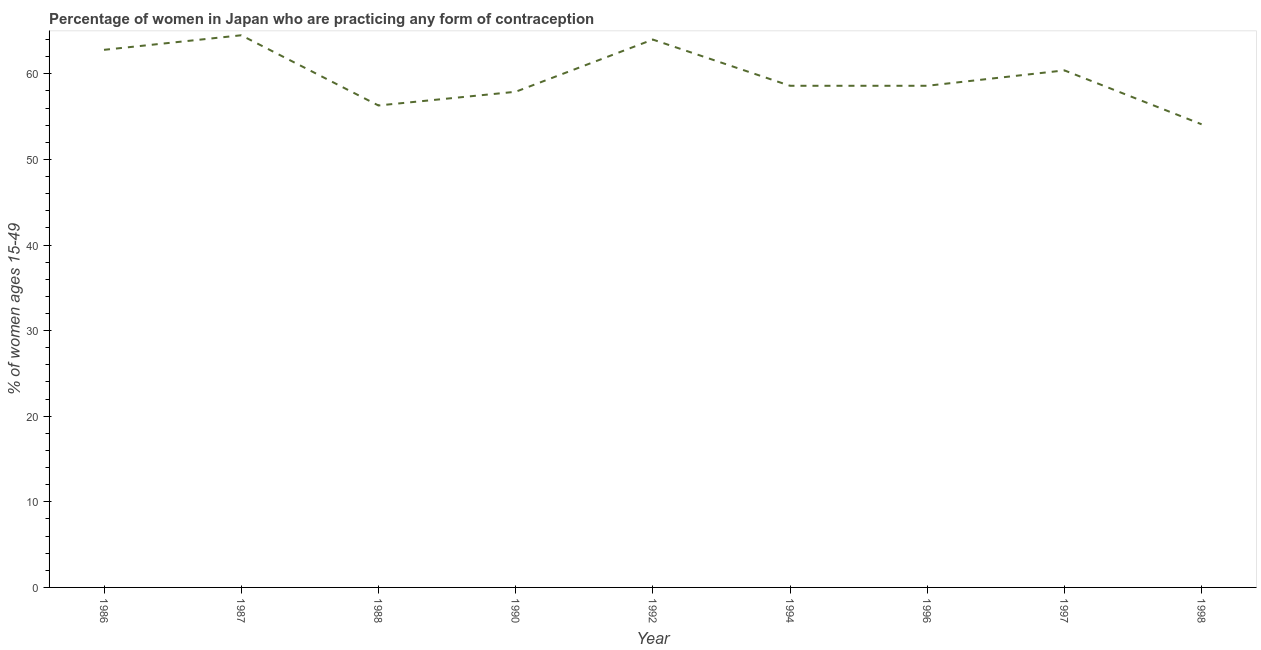What is the contraceptive prevalence in 1992?
Your answer should be compact. 64. Across all years, what is the maximum contraceptive prevalence?
Offer a terse response. 64.5. Across all years, what is the minimum contraceptive prevalence?
Provide a succinct answer. 54.1. In which year was the contraceptive prevalence minimum?
Keep it short and to the point. 1998. What is the sum of the contraceptive prevalence?
Offer a very short reply. 537.2. What is the difference between the contraceptive prevalence in 1988 and 1997?
Offer a terse response. -4.1. What is the average contraceptive prevalence per year?
Provide a succinct answer. 59.69. What is the median contraceptive prevalence?
Keep it short and to the point. 58.6. In how many years, is the contraceptive prevalence greater than 62 %?
Make the answer very short. 3. What is the ratio of the contraceptive prevalence in 1987 to that in 1990?
Give a very brief answer. 1.11. Is the difference between the contraceptive prevalence in 1992 and 1994 greater than the difference between any two years?
Your response must be concise. No. What is the difference between the highest and the second highest contraceptive prevalence?
Your answer should be compact. 0.5. What is the difference between the highest and the lowest contraceptive prevalence?
Make the answer very short. 10.4. In how many years, is the contraceptive prevalence greater than the average contraceptive prevalence taken over all years?
Provide a short and direct response. 4. Does the contraceptive prevalence monotonically increase over the years?
Your answer should be very brief. No. How many years are there in the graph?
Your response must be concise. 9. What is the difference between two consecutive major ticks on the Y-axis?
Make the answer very short. 10. Are the values on the major ticks of Y-axis written in scientific E-notation?
Provide a succinct answer. No. What is the title of the graph?
Make the answer very short. Percentage of women in Japan who are practicing any form of contraception. What is the label or title of the X-axis?
Your answer should be very brief. Year. What is the label or title of the Y-axis?
Your answer should be very brief. % of women ages 15-49. What is the % of women ages 15-49 of 1986?
Ensure brevity in your answer.  62.8. What is the % of women ages 15-49 of 1987?
Make the answer very short. 64.5. What is the % of women ages 15-49 of 1988?
Provide a succinct answer. 56.3. What is the % of women ages 15-49 of 1990?
Make the answer very short. 57.9. What is the % of women ages 15-49 in 1994?
Offer a very short reply. 58.6. What is the % of women ages 15-49 of 1996?
Your answer should be compact. 58.6. What is the % of women ages 15-49 in 1997?
Provide a short and direct response. 60.4. What is the % of women ages 15-49 in 1998?
Keep it short and to the point. 54.1. What is the difference between the % of women ages 15-49 in 1986 and 1987?
Make the answer very short. -1.7. What is the difference between the % of women ages 15-49 in 1986 and 1992?
Offer a very short reply. -1.2. What is the difference between the % of women ages 15-49 in 1986 and 1996?
Offer a terse response. 4.2. What is the difference between the % of women ages 15-49 in 1986 and 1997?
Offer a terse response. 2.4. What is the difference between the % of women ages 15-49 in 1987 and 1988?
Offer a very short reply. 8.2. What is the difference between the % of women ages 15-49 in 1987 and 1990?
Your answer should be compact. 6.6. What is the difference between the % of women ages 15-49 in 1987 and 1994?
Your answer should be very brief. 5.9. What is the difference between the % of women ages 15-49 in 1988 and 1990?
Your response must be concise. -1.6. What is the difference between the % of women ages 15-49 in 1988 and 1992?
Offer a terse response. -7.7. What is the difference between the % of women ages 15-49 in 1988 and 1996?
Your response must be concise. -2.3. What is the difference between the % of women ages 15-49 in 1988 and 1997?
Give a very brief answer. -4.1. What is the difference between the % of women ages 15-49 in 1988 and 1998?
Make the answer very short. 2.2. What is the difference between the % of women ages 15-49 in 1990 and 1998?
Your response must be concise. 3.8. What is the difference between the % of women ages 15-49 in 1992 and 1994?
Your response must be concise. 5.4. What is the difference between the % of women ages 15-49 in 1992 and 1996?
Offer a terse response. 5.4. What is the difference between the % of women ages 15-49 in 1992 and 1998?
Offer a terse response. 9.9. What is the difference between the % of women ages 15-49 in 1994 and 1996?
Offer a very short reply. 0. What is the difference between the % of women ages 15-49 in 1994 and 1998?
Ensure brevity in your answer.  4.5. What is the difference between the % of women ages 15-49 in 1996 and 1997?
Make the answer very short. -1.8. What is the difference between the % of women ages 15-49 in 1996 and 1998?
Keep it short and to the point. 4.5. What is the ratio of the % of women ages 15-49 in 1986 to that in 1987?
Your answer should be compact. 0.97. What is the ratio of the % of women ages 15-49 in 1986 to that in 1988?
Provide a short and direct response. 1.11. What is the ratio of the % of women ages 15-49 in 1986 to that in 1990?
Give a very brief answer. 1.08. What is the ratio of the % of women ages 15-49 in 1986 to that in 1992?
Ensure brevity in your answer.  0.98. What is the ratio of the % of women ages 15-49 in 1986 to that in 1994?
Your answer should be very brief. 1.07. What is the ratio of the % of women ages 15-49 in 1986 to that in 1996?
Offer a terse response. 1.07. What is the ratio of the % of women ages 15-49 in 1986 to that in 1998?
Your response must be concise. 1.16. What is the ratio of the % of women ages 15-49 in 1987 to that in 1988?
Your response must be concise. 1.15. What is the ratio of the % of women ages 15-49 in 1987 to that in 1990?
Provide a short and direct response. 1.11. What is the ratio of the % of women ages 15-49 in 1987 to that in 1994?
Your answer should be compact. 1.1. What is the ratio of the % of women ages 15-49 in 1987 to that in 1996?
Your response must be concise. 1.1. What is the ratio of the % of women ages 15-49 in 1987 to that in 1997?
Your answer should be very brief. 1.07. What is the ratio of the % of women ages 15-49 in 1987 to that in 1998?
Offer a very short reply. 1.19. What is the ratio of the % of women ages 15-49 in 1988 to that in 1990?
Ensure brevity in your answer.  0.97. What is the ratio of the % of women ages 15-49 in 1988 to that in 1992?
Your answer should be very brief. 0.88. What is the ratio of the % of women ages 15-49 in 1988 to that in 1997?
Provide a succinct answer. 0.93. What is the ratio of the % of women ages 15-49 in 1988 to that in 1998?
Offer a very short reply. 1.04. What is the ratio of the % of women ages 15-49 in 1990 to that in 1992?
Your answer should be very brief. 0.91. What is the ratio of the % of women ages 15-49 in 1990 to that in 1994?
Your answer should be compact. 0.99. What is the ratio of the % of women ages 15-49 in 1990 to that in 1997?
Provide a short and direct response. 0.96. What is the ratio of the % of women ages 15-49 in 1990 to that in 1998?
Offer a very short reply. 1.07. What is the ratio of the % of women ages 15-49 in 1992 to that in 1994?
Ensure brevity in your answer.  1.09. What is the ratio of the % of women ages 15-49 in 1992 to that in 1996?
Your answer should be compact. 1.09. What is the ratio of the % of women ages 15-49 in 1992 to that in 1997?
Make the answer very short. 1.06. What is the ratio of the % of women ages 15-49 in 1992 to that in 1998?
Ensure brevity in your answer.  1.18. What is the ratio of the % of women ages 15-49 in 1994 to that in 1996?
Give a very brief answer. 1. What is the ratio of the % of women ages 15-49 in 1994 to that in 1998?
Keep it short and to the point. 1.08. What is the ratio of the % of women ages 15-49 in 1996 to that in 1997?
Your response must be concise. 0.97. What is the ratio of the % of women ages 15-49 in 1996 to that in 1998?
Make the answer very short. 1.08. What is the ratio of the % of women ages 15-49 in 1997 to that in 1998?
Make the answer very short. 1.12. 